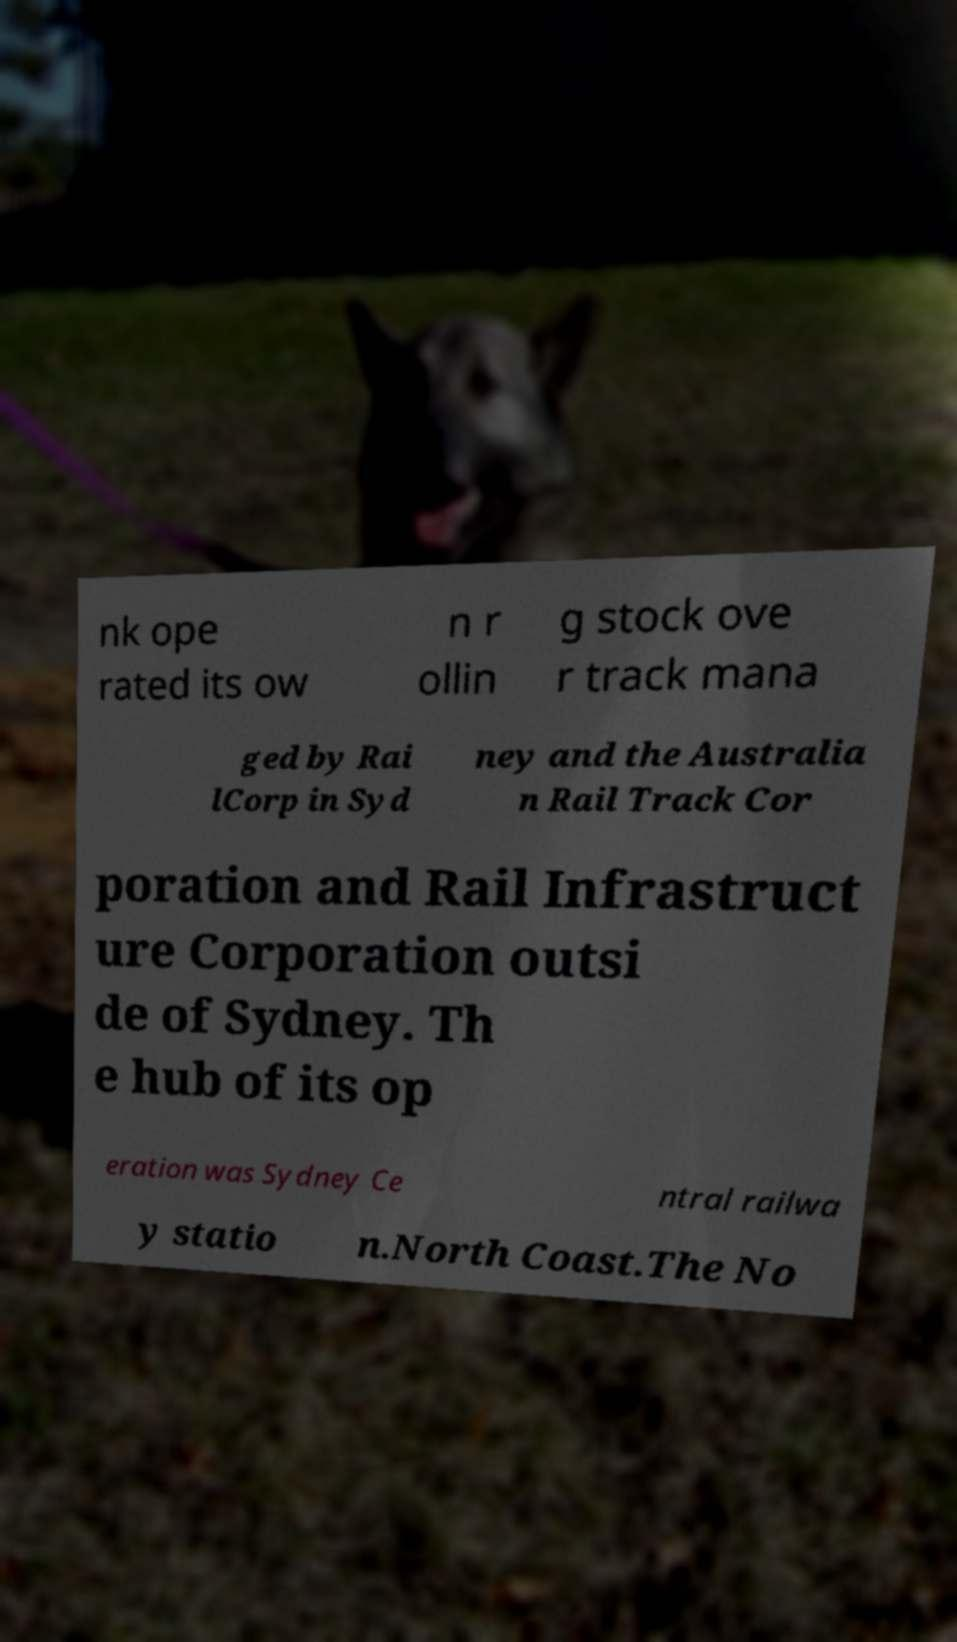I need the written content from this picture converted into text. Can you do that? nk ope rated its ow n r ollin g stock ove r track mana ged by Rai lCorp in Syd ney and the Australia n Rail Track Cor poration and Rail Infrastruct ure Corporation outsi de of Sydney. Th e hub of its op eration was Sydney Ce ntral railwa y statio n.North Coast.The No 